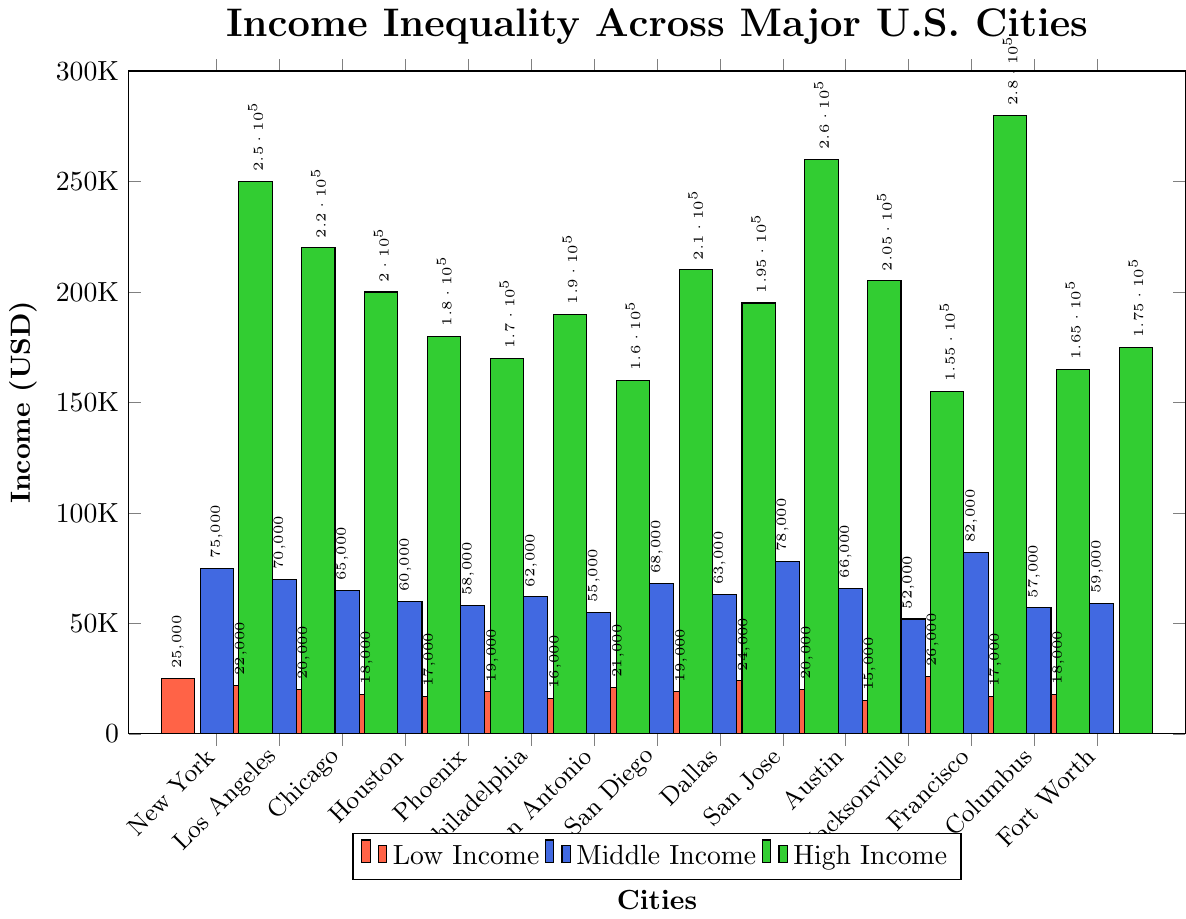What is the highest income level for low-income groups across the cities? By looking at the bar heights in red color representing low-income groups, the tallest bar is for San Francisco, indicating the highest income level for this group.
Answer: San Francisco Which city has the smallest difference between middle and high-income levels? Compute the difference between the middle and high-income levels for each city (New York: 175000, Los Angeles: 150000, etc.). The city with the smallest difference is Jacksonville (103000).
Answer: Jacksonville What is the median income level for high-income groups? List the income values for high-income groups, sort them (155000, 160000, ..., 280000), and find the middle value. Here the sorted incomes are 155000, 160000, ..., 280000, and the median is the middle value (200000).
Answer: 200000 Which city shows the greatest disparity between low-income and high-income levels? Calculate the disparity (difference) between low and high-income levels for each city (New York: 225000, Los Angeles: 198000, etc.). The greatest disparity is observed in San Francisco.
Answer: San Francisco In which city is the middle-income level closest to the high-income level of another city? Identify the middle-income levels and compare them with each high-income level across different cities. Austin's middle-income level (66000) is closest to the high-income level for Jacksonville (66000 - 155000 = -89000).
Answer: Austin and Jacksonville Which city has a high-income level that is equal to or greater than 250,000 but less than 280,000? Look for green bars that fall between 250,000 and 280,000. San Francisco and San Jose meet this criterion.
Answer: San Francisco, San Jose What is the cumulative income for low-income groups across all cities? Sum low-income levels: 25000 + 22000 + 20000 + 18000 + 17000 + 19000 + 16000 + 21000 + 19000 + 24000 + 20000 + 15000 + 26000 + 17000 + 18000 = 311000
Answer: 311000 What is the average middle-income level for all cities? Sum middle-income levels and divide by the number of cities: (75000 + 70000 + 65000 + 60000 + 58000 + 62000 + 55000 + 68000 + 63000 + 78000 + 66000 + 52000 + 82000 + 57000 + 59000) / 15, which equals 65333.33.
Answer: 65333.33 Which three cities have the highest low-income levels? Identify the cities with the tallest red bars for low-income groups. The top three bars represent San Francisco, New York City, and San Jose.
Answer: San Francisco, New York City, San Jose Which city has the least income inequality between low and middle-income levels? Calculate the differences between low and middle-income levels for all cities (New York: 50000, Los Angeles: 48000, etc.). The smallest difference is found in Phoenix (41000).
Answer: Phoenix 